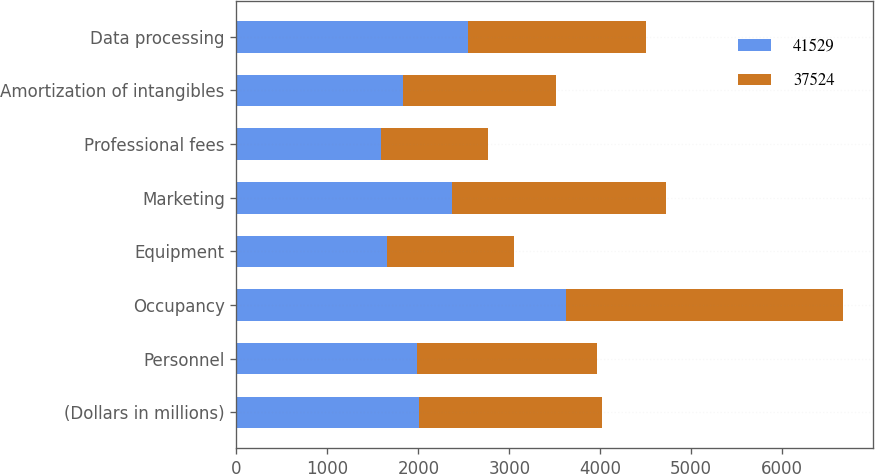Convert chart to OTSL. <chart><loc_0><loc_0><loc_500><loc_500><stacked_bar_chart><ecel><fcel>(Dollars in millions)<fcel>Personnel<fcel>Occupancy<fcel>Equipment<fcel>Marketing<fcel>Professional fees<fcel>Amortization of intangibles<fcel>Data processing<nl><fcel>41529<fcel>2008<fcel>1984.5<fcel>3626<fcel>1655<fcel>2368<fcel>1592<fcel>1834<fcel>2546<nl><fcel>37524<fcel>2007<fcel>1984.5<fcel>3038<fcel>1391<fcel>2356<fcel>1174<fcel>1676<fcel>1962<nl></chart> 